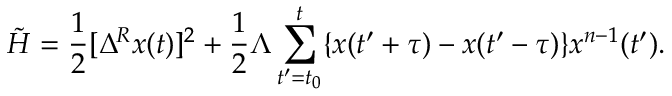<formula> <loc_0><loc_0><loc_500><loc_500>\tilde { H } = \frac { 1 } { 2 } [ \Delta ^ { R } x ( t ) ] ^ { 2 } + \frac { 1 } { 2 } \Lambda \sum _ { t ^ { \prime } = t _ { 0 } } ^ { t } \{ x ( t ^ { \prime } + \tau ) - x ( t ^ { \prime } - \tau ) \} x ^ { n - 1 } ( t ^ { \prime } ) .</formula> 